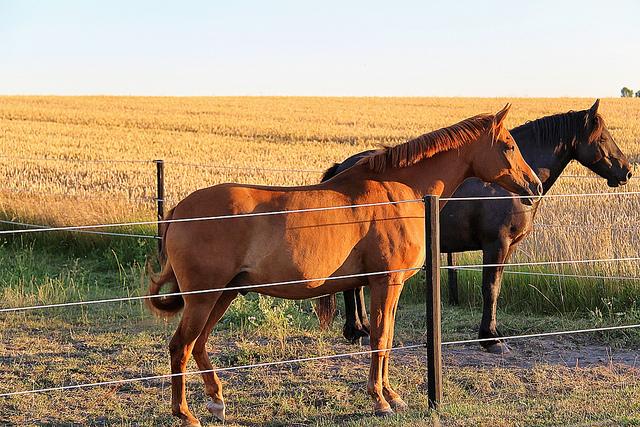How many animals are here?
Concise answer only. 2. Are the horses moving?
Concise answer only. No. What is harvested?
Quick response, please. Wheat. 